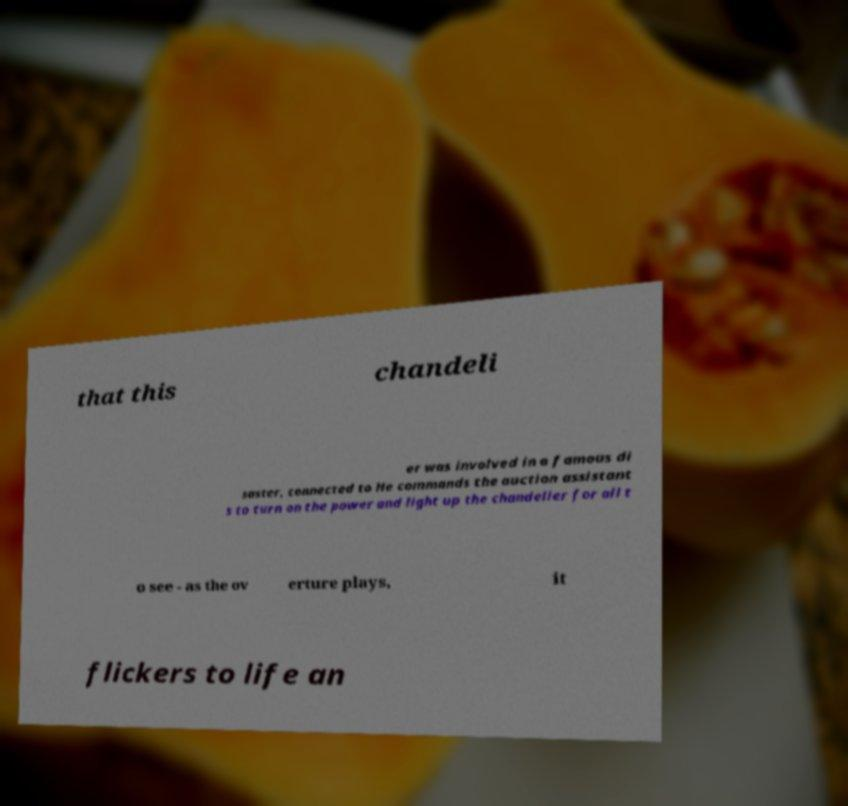Could you assist in decoding the text presented in this image and type it out clearly? that this chandeli er was involved in a famous di saster, connected to He commands the auction assistant s to turn on the power and light up the chandelier for all t o see - as the ov erture plays, it flickers to life an 